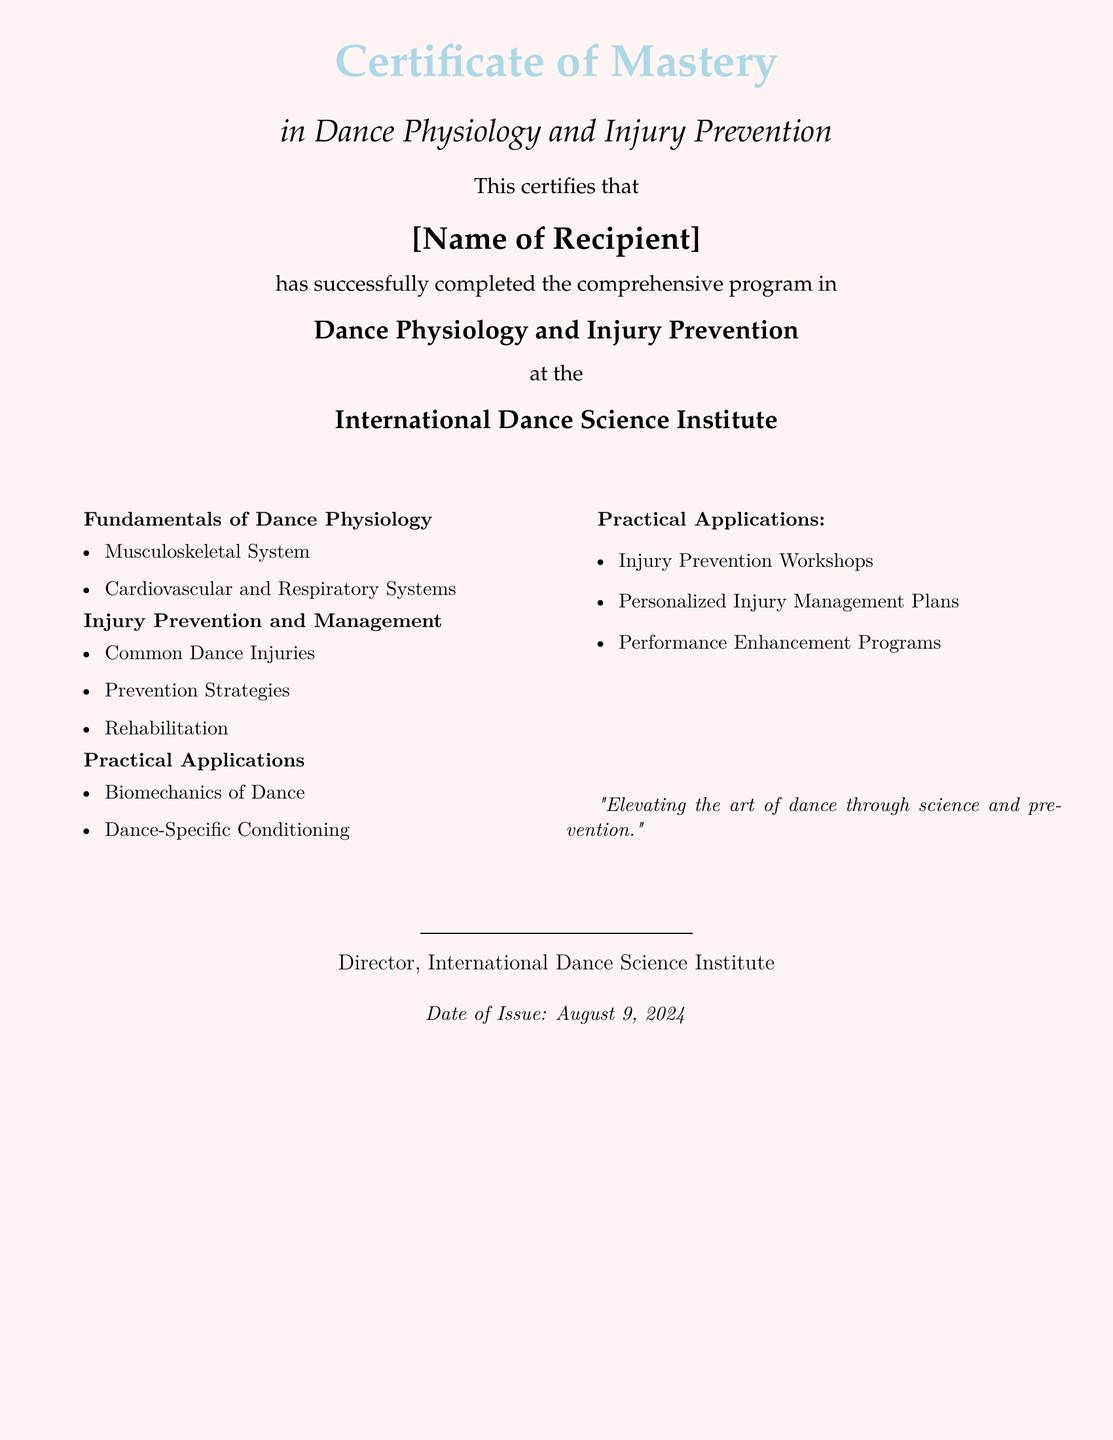What is the name of the recipient? The recipient's name should be filled in the designated area on the certificate, currently noted as [Name of Recipient].
Answer: [Name of Recipient] What is the title of the certificate? The title displayed prominently on the document indicates the certificate being awarded.
Answer: Certificate of Mastery Where was the course completed? The organization that issued the certificate is mentioned clearly in the document.
Answer: International Dance Science Institute What are the focus areas of the fundamental course? The specific subjects covered in the course section are listed under the fundamentals of dance physiology.
Answer: Musculoskeletal System, Cardiovascular and Respiratory Systems What is one of the practical applications mentioned? The document specifies types of activities that apply the knowledge from the course.
Answer: Injury Prevention Workshops How many modules are listed in the injury prevention section? The document outlines the specific modules included in the injury prevention and management course.
Answer: Three What is the date of issue for the certificate? The date is noted at the bottom of the certificate format.
Answer: Today Who signed the certificate? The position of the individual who authorized the certificate is mentioned at the end of the document.
Answer: Director, International Dance Science Institute 